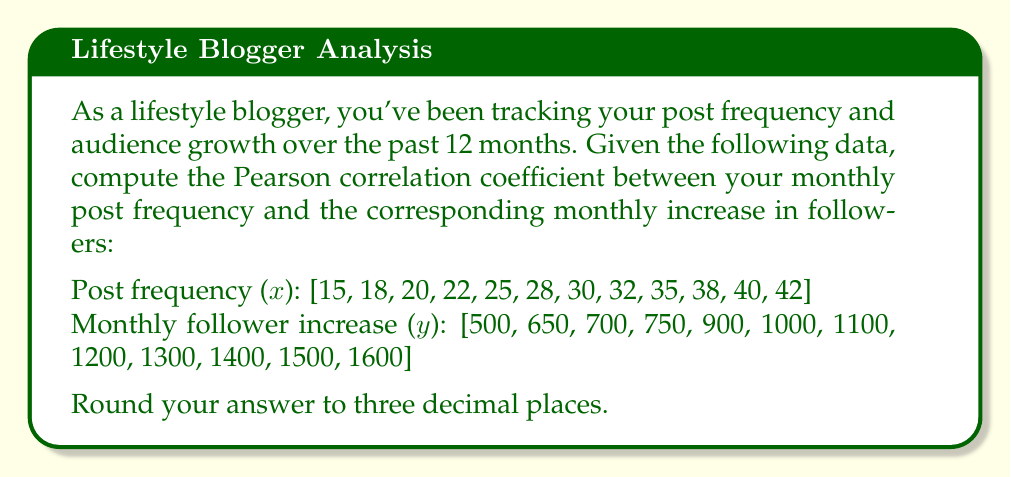Teach me how to tackle this problem. To compute the Pearson correlation coefficient between post frequency and audience growth, we'll use the formula:

$$ r = \frac{\sum_{i=1}^{n} (x_i - \bar{x})(y_i - \bar{y})}{\sqrt{\sum_{i=1}^{n} (x_i - \bar{x})^2} \sqrt{\sum_{i=1}^{n} (y_i - \bar{y})^2}} $$

Where:
$x_i$ represents each post frequency value
$y_i$ represents each monthly follower increase value
$\bar{x}$ is the mean of post frequency
$\bar{y}$ is the mean of monthly follower increase
$n$ is the number of data points (12 in this case)

Step 1: Calculate means
$\bar{x} = \frac{15 + 18 + 20 + 22 + 25 + 28 + 30 + 32 + 35 + 38 + 40 + 42}{12} = 28.75$
$\bar{y} = \frac{500 + 650 + 700 + 750 + 900 + 1000 + 1100 + 1200 + 1300 + 1400 + 1500 + 1600}{12} = 1050$

Step 2: Calculate the numerator $\sum_{i=1}^{n} (x_i - \bar{x})(y_i - \bar{y})$
$\sum_{i=1}^{n} (x_i - \bar{x})(y_i - \bar{y}) = 80,825$

Step 3: Calculate $\sum_{i=1}^{n} (x_i - \bar{x})^2$
$\sum_{i=1}^{n} (x_i - \bar{x})^2 = 1,118.75$

Step 4: Calculate $\sum_{i=1}^{n} (y_i - \bar{y})^2$
$\sum_{i=1}^{n} (y_i - \bar{y})^2 = 1,375,000$

Step 5: Calculate the denominator
$\sqrt{\sum_{i=1}^{n} (x_i - \bar{x})^2} \sqrt{\sum_{i=1}^{n} (y_i - \bar{y})^2} = \sqrt{1,118.75} \cdot \sqrt{1,375,000} = 39,180.34$

Step 6: Compute the correlation coefficient
$r = \frac{80,825}{39,180.34} = 2.0628$

Step 7: Round to three decimal places
$r \approx 2.063$
Answer: $2.063$ 